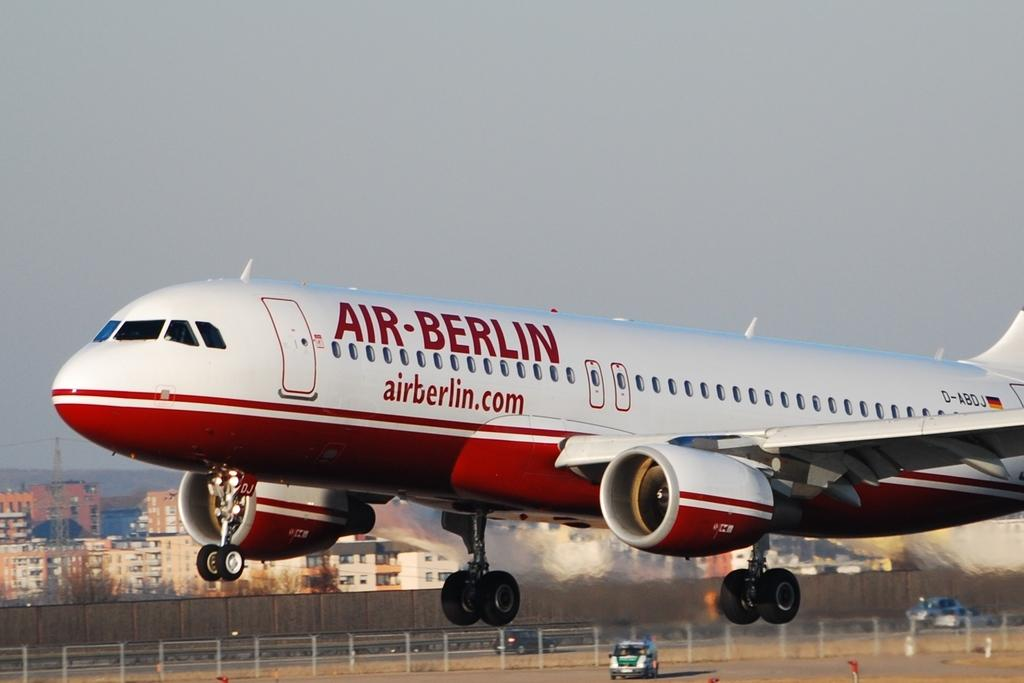<image>
Summarize the visual content of the image. A plane from Air-Berlin is either in mid-takeoff or mid-landing. 